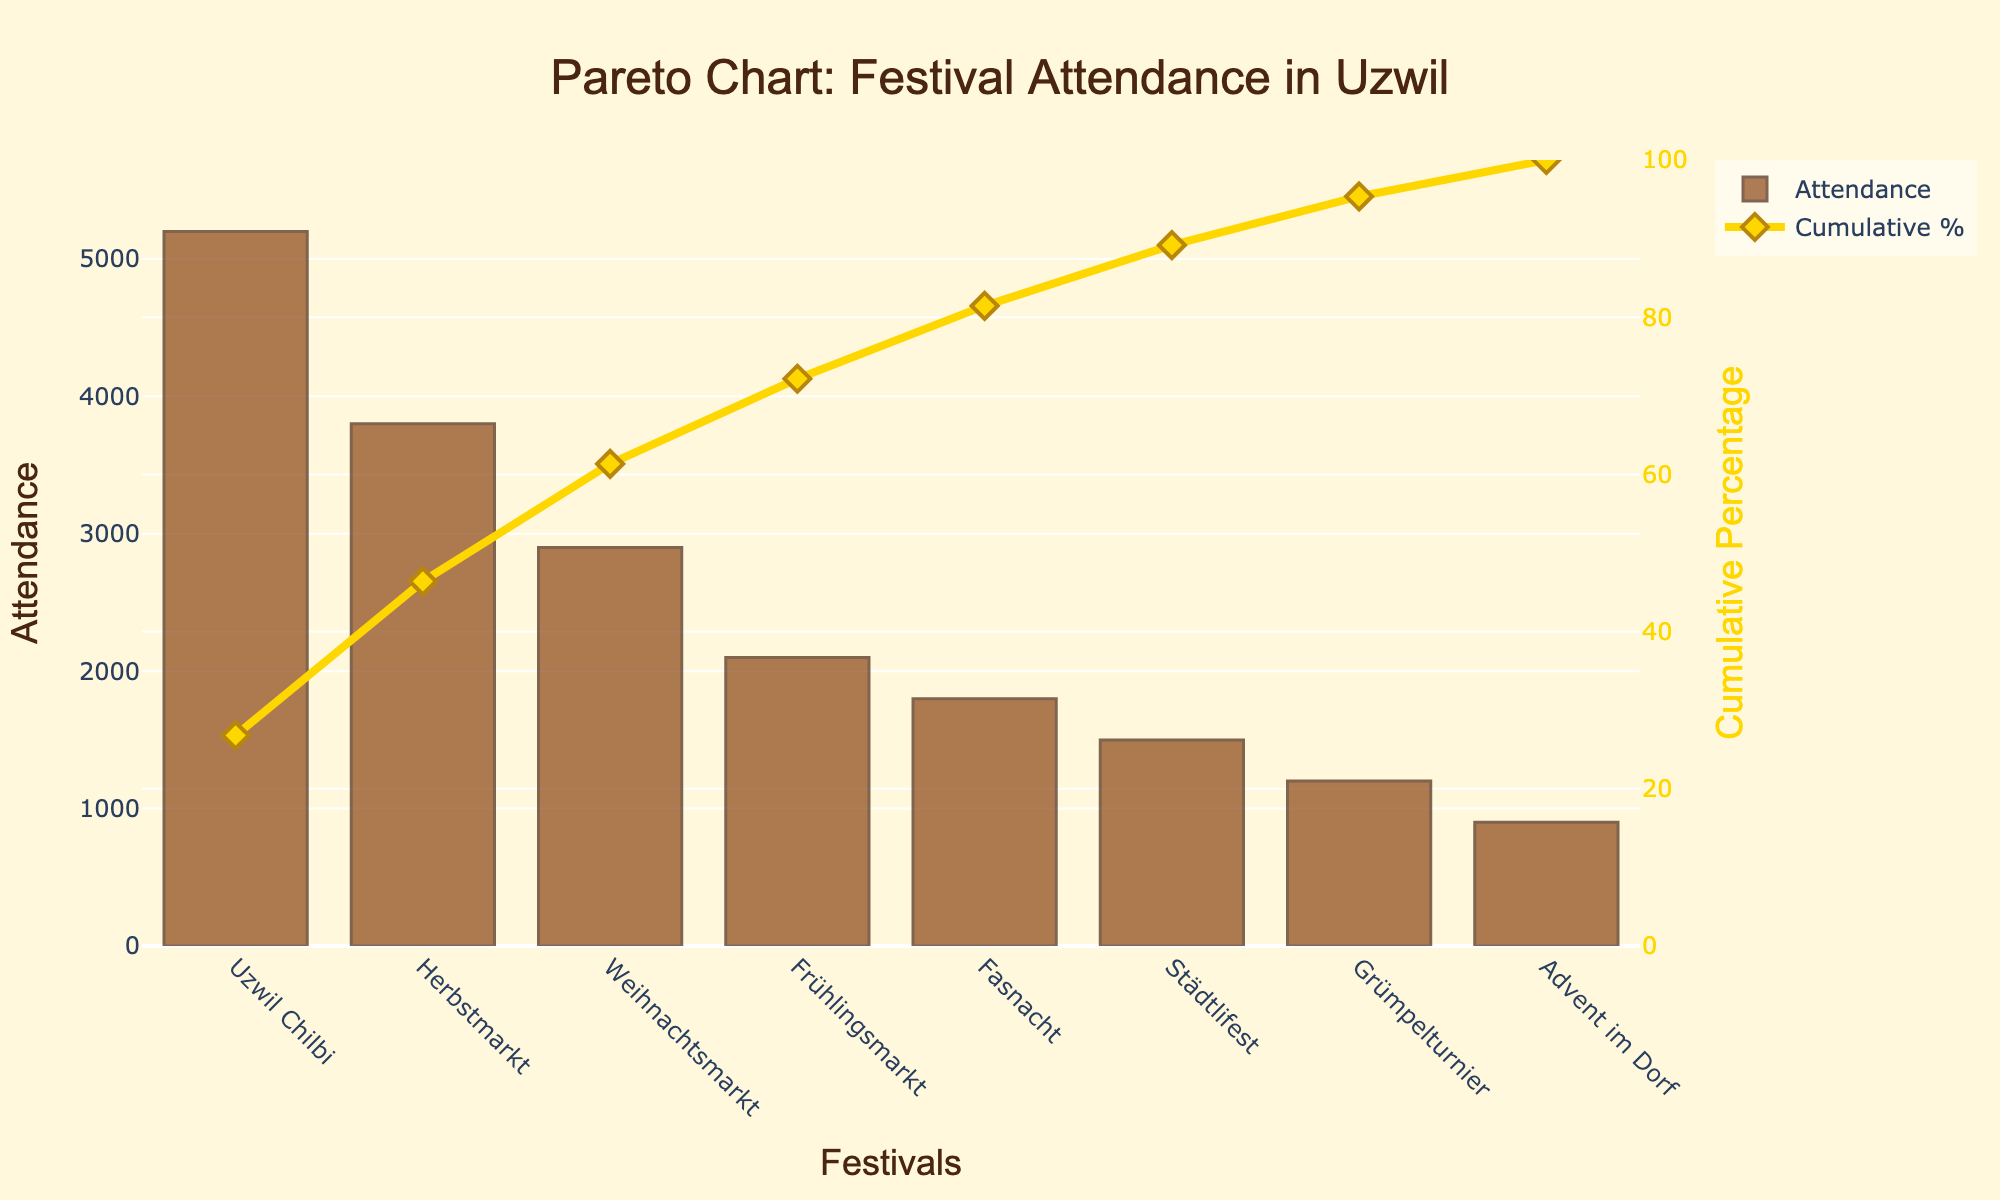what is the title of the chart? The title can be found at the top of the chart. It reads "Pareto Chart: Festival Attendance in Uzwil".
Answer: Pareto Chart: Festival Attendance in Uzwil Which festival has the highest attendance? By looking at the bars, the tallest bar represents the Uzwil Chilbi, indicating it has the highest attendance.
Answer: Uzwil Chilbi What color represents the attendance bars? The bars representing attendance are colored with a brownish hue.
Answer: Brown What is the cumulative percentage of attendance after the Herbstmarkt festival? To find this, refer to the cumulative percentage line (gold line) and check its value over the Herbstmarkt festival. This cumulative percentage reaches 62.5%.
Answer: 62.5% What is the attendance difference between the Uzwil Chilbi and the Fasnacht? Uzwil Chilbi has an attendance of 5200, and Fasnacht has 1800. The difference is calculated as 5200 - 1800 = 3400.
Answer: 3400 Which festival is represented by the last bar on the x-axis? By following the x-axis from left to right, the last bar represents the Advent im Dorf festival.
Answer: Advent im Dorf What's the sum of attendances for the top three festivals? The top three festivals based on attendance are Uzwil Chilbi (5200), Herbstmarkt (3800), and Weihnachtsmarkt (2900). Summing these gives: 5200 + 3800 + 2900 = 11900.
Answer: 11900 At which festival does the cumulative percentage first exceed 75%? To find this, trace the cumulative percentage line. It exceeds 75% after the Weihnachtsmarkt (74.52%) and before Frühlingsmarkt (87.1%). So, it first exceeds 75% at Frühlingsmarkt.
Answer: Frühlingsmarkt How many festivals have an attendance greater than 2000? Counting the bars with heights larger than 2000, there are four such festivals: Uzwil Chilbi, Herbstmarkt, Weihnachtsmarkt, Frühlingsmarkt.
Answer: 4 What is the cumulative percentage at Fasnacht? Trace the cumulative percentage line at the Fasnacht festival. It reaches up to 88.71%.
Answer: 88.71% What percentage of the total attendance is accounted for by the Uzwil Chilbi and Herbstmarkt combined? Combined attendance for Uzwil Chilbi (5200) and Herbstmarkt (3800) equals 9000. Total attendance is 21400. (9000 / 21400) * 100 = 42.06%.
Answer: 42.06% 